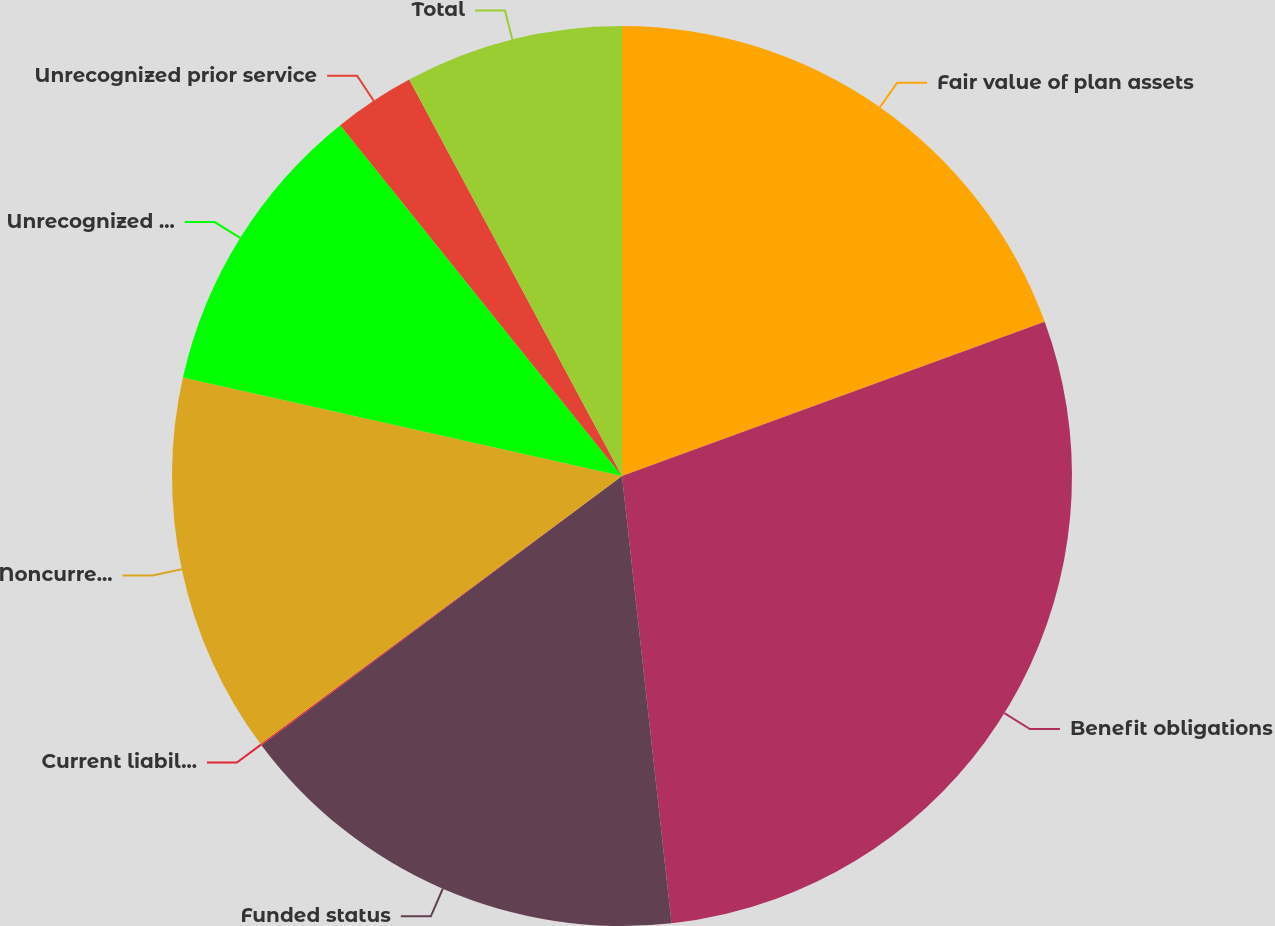<chart> <loc_0><loc_0><loc_500><loc_500><pie_chart><fcel>Fair value of plan assets<fcel>Benefit obligations<fcel>Funded status<fcel>Current liabilities-accrued<fcel>Noncurrent liabilities-other<fcel>Unrecognized net actuarial<fcel>Unrecognized prior service<fcel>Total<nl><fcel>19.43%<fcel>28.82%<fcel>16.55%<fcel>0.05%<fcel>13.67%<fcel>10.72%<fcel>2.93%<fcel>7.84%<nl></chart> 